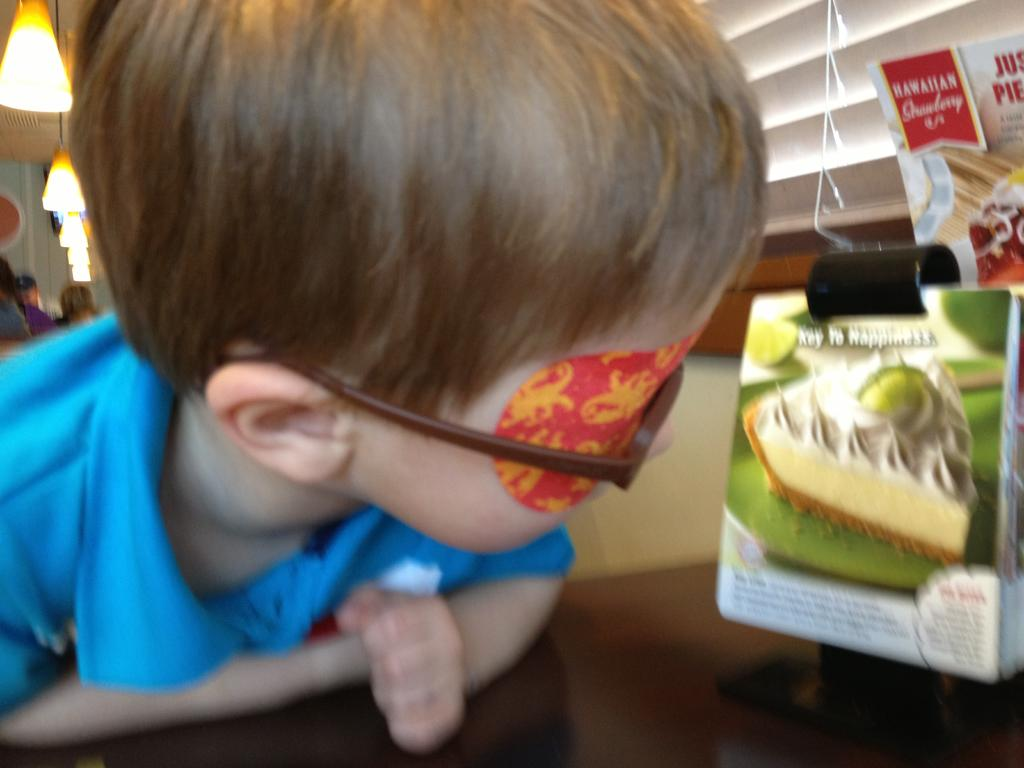What is on the left side of the image? There is a boy on the left side of the image. What is the boy wearing? The boy is wearing a blue T-shirt. What is the boy doing in the image? The boy is leaning on a table. What can be seen on the table in the image? There are posters arranged on the table. What is visible in the background of the image? There are lights, persons, and other objects in the background of the image. What type of wrench is the boy using in the image? There is no wrench present in the image; the boy is leaning on a table with posters arranged on it. 